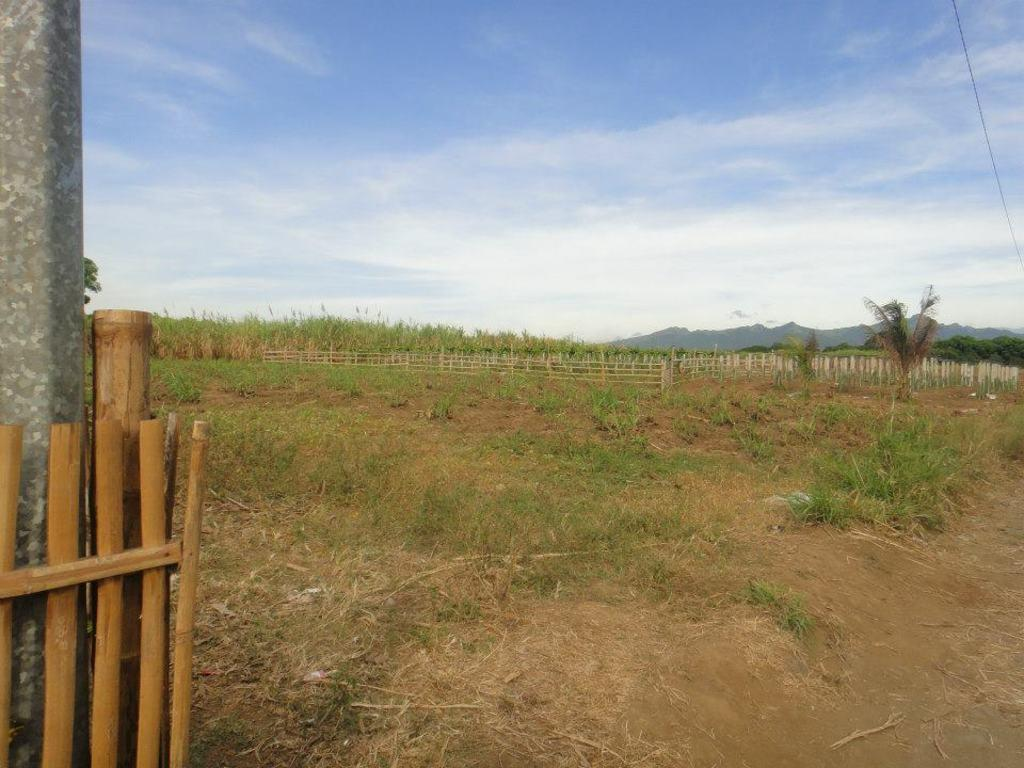What type of fence is in the image? There is a wooden fence in the image. What type of vegetation is present in the image? Grass is present in the image. What other structures can be seen in the image? There is a metal pole in the image. What natural features are visible in the image? Trees and hills are present in the image. How would you describe the sky in the image? The sky is cloudy and pale blue. Can you tell me how many yaks are grazing on the grass in the image? There are no yaks present in the image; it features a wooden fence, grass, a metal pole, trees, hills, and a cloudy, pale blue sky. What type of soda is being advertised on the metal pole in the image? There is no soda or advertisement present on the metal pole in the image. 